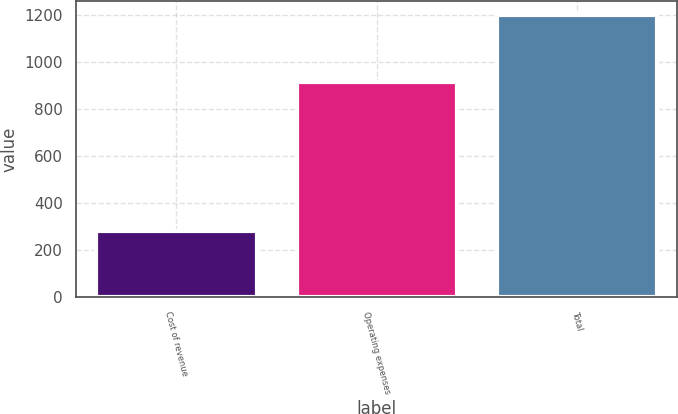Convert chart to OTSL. <chart><loc_0><loc_0><loc_500><loc_500><bar_chart><fcel>Cost of revenue<fcel>Operating expenses<fcel>Total<nl><fcel>281.1<fcel>915.5<fcel>1196.6<nl></chart> 